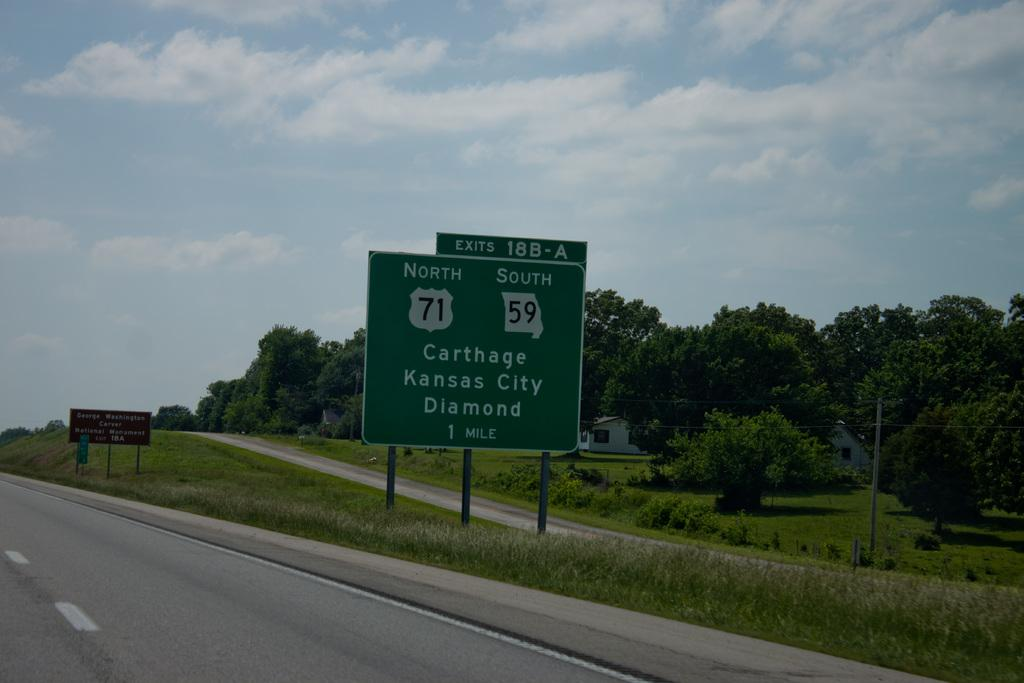<image>
Create a compact narrative representing the image presented. A green and white highway sign for carthage Kansas city Diamond is one mile away. 